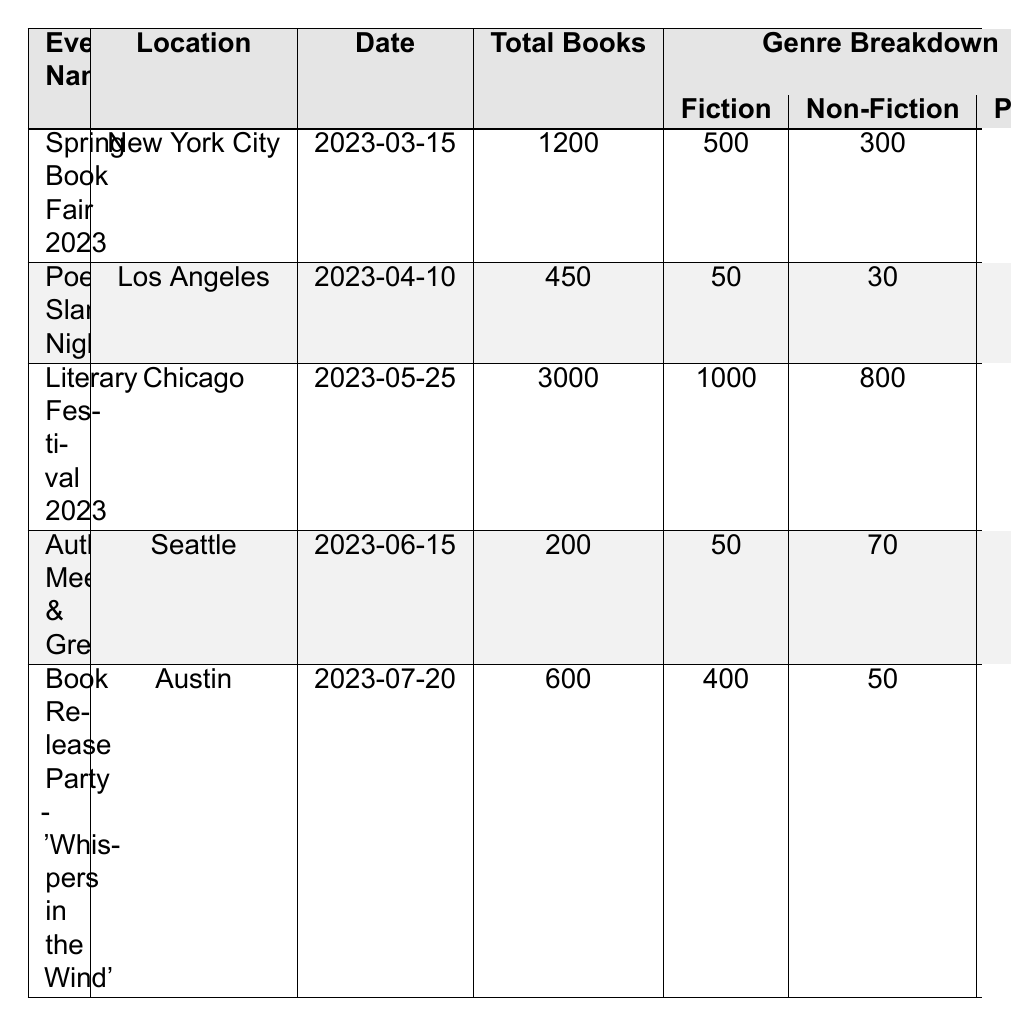What is the total number of books sold at the Literary Festival 2023? The table shows that the total books sold at the Literary Festival 2023 is listed under the "Total Books" column. The corresponding value is 3000.
Answer: 3000 How many poetry books were sold at the Poetry Slam Night? According to the genre breakdown for the Poetry Slam Night, the number of poetry books sold is 350.
Answer: 350 What was the location of the Spring Book Fair 2023? The location of the Spring Book Fair 2023 is found in the "Location" column. It is listed as New York City.
Answer: New York City Which event sold the least number of total books? To find this, we compare the "Total Books" column across all events. The Author Meet & Greet sold 200 total books, which is the least.
Answer: Author Meet & Greet How many total books were sold at the Author Meet & Greet compared to the Book Release Party? The total books sold at the Author Meet & Greet is 200, while the Book Release Party sold 600. The difference is 600 - 200 = 400.
Answer: 400 Calculate the average number of fiction books sold across all events. First, we sum the fiction books sold: 500 (Spring Book Fair) + 50 (Poetry Slam Night) + 1000 (Literary Festival) + 50 (Author Meet & Greet) + 400 (Book Release Party) = 2000. Since there are 5 events, the average is 2000 / 5 = 400.
Answer: 400 Did more nonfiction or poetry books sell at the Literary Festival 2023? For this event, 800 nonfiction books and 400 poetry books were sold. Since 800 is greater than 400, more nonfiction books were sold.
Answer: Yes, nonfiction books sold more What percentage of total books sold at the Spring Book Fair 2023 were fiction? The total books sold at the Spring Book Fair is 1200, and the number of fiction books sold is 500. The percentage of fiction books is calculated as (500/1200) * 100 = 41.67%.
Answer: 41.67% Which event featured the highest number of featured authors? The Literary Festival 2023 lists 3 featured authors, while other events have fewer (Spring Book Fair has 3, Poetry Slam Night has 2, Author Meet & Greet has 2, Book Release Party has 1). Thus, both the Literary Festival 2023 and the Spring Book Fair have the highest number of featured authors.
Answer: Literary Festival 2023 and Spring Book Fair How many total books were sold at events held in June? The only event in June is the Author Meet & Greet, which sold 200 total books.
Answer: 200 